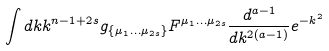<formula> <loc_0><loc_0><loc_500><loc_500>\int d k k ^ { n - 1 + 2 s } g _ { \{ \mu _ { 1 } \dots \mu _ { 2 s } \} } F ^ { \mu _ { 1 } \dots \mu _ { 2 s } } \frac { d ^ { a - 1 } } { d k ^ { 2 ( a - 1 ) } } e ^ { - k ^ { 2 } }</formula> 